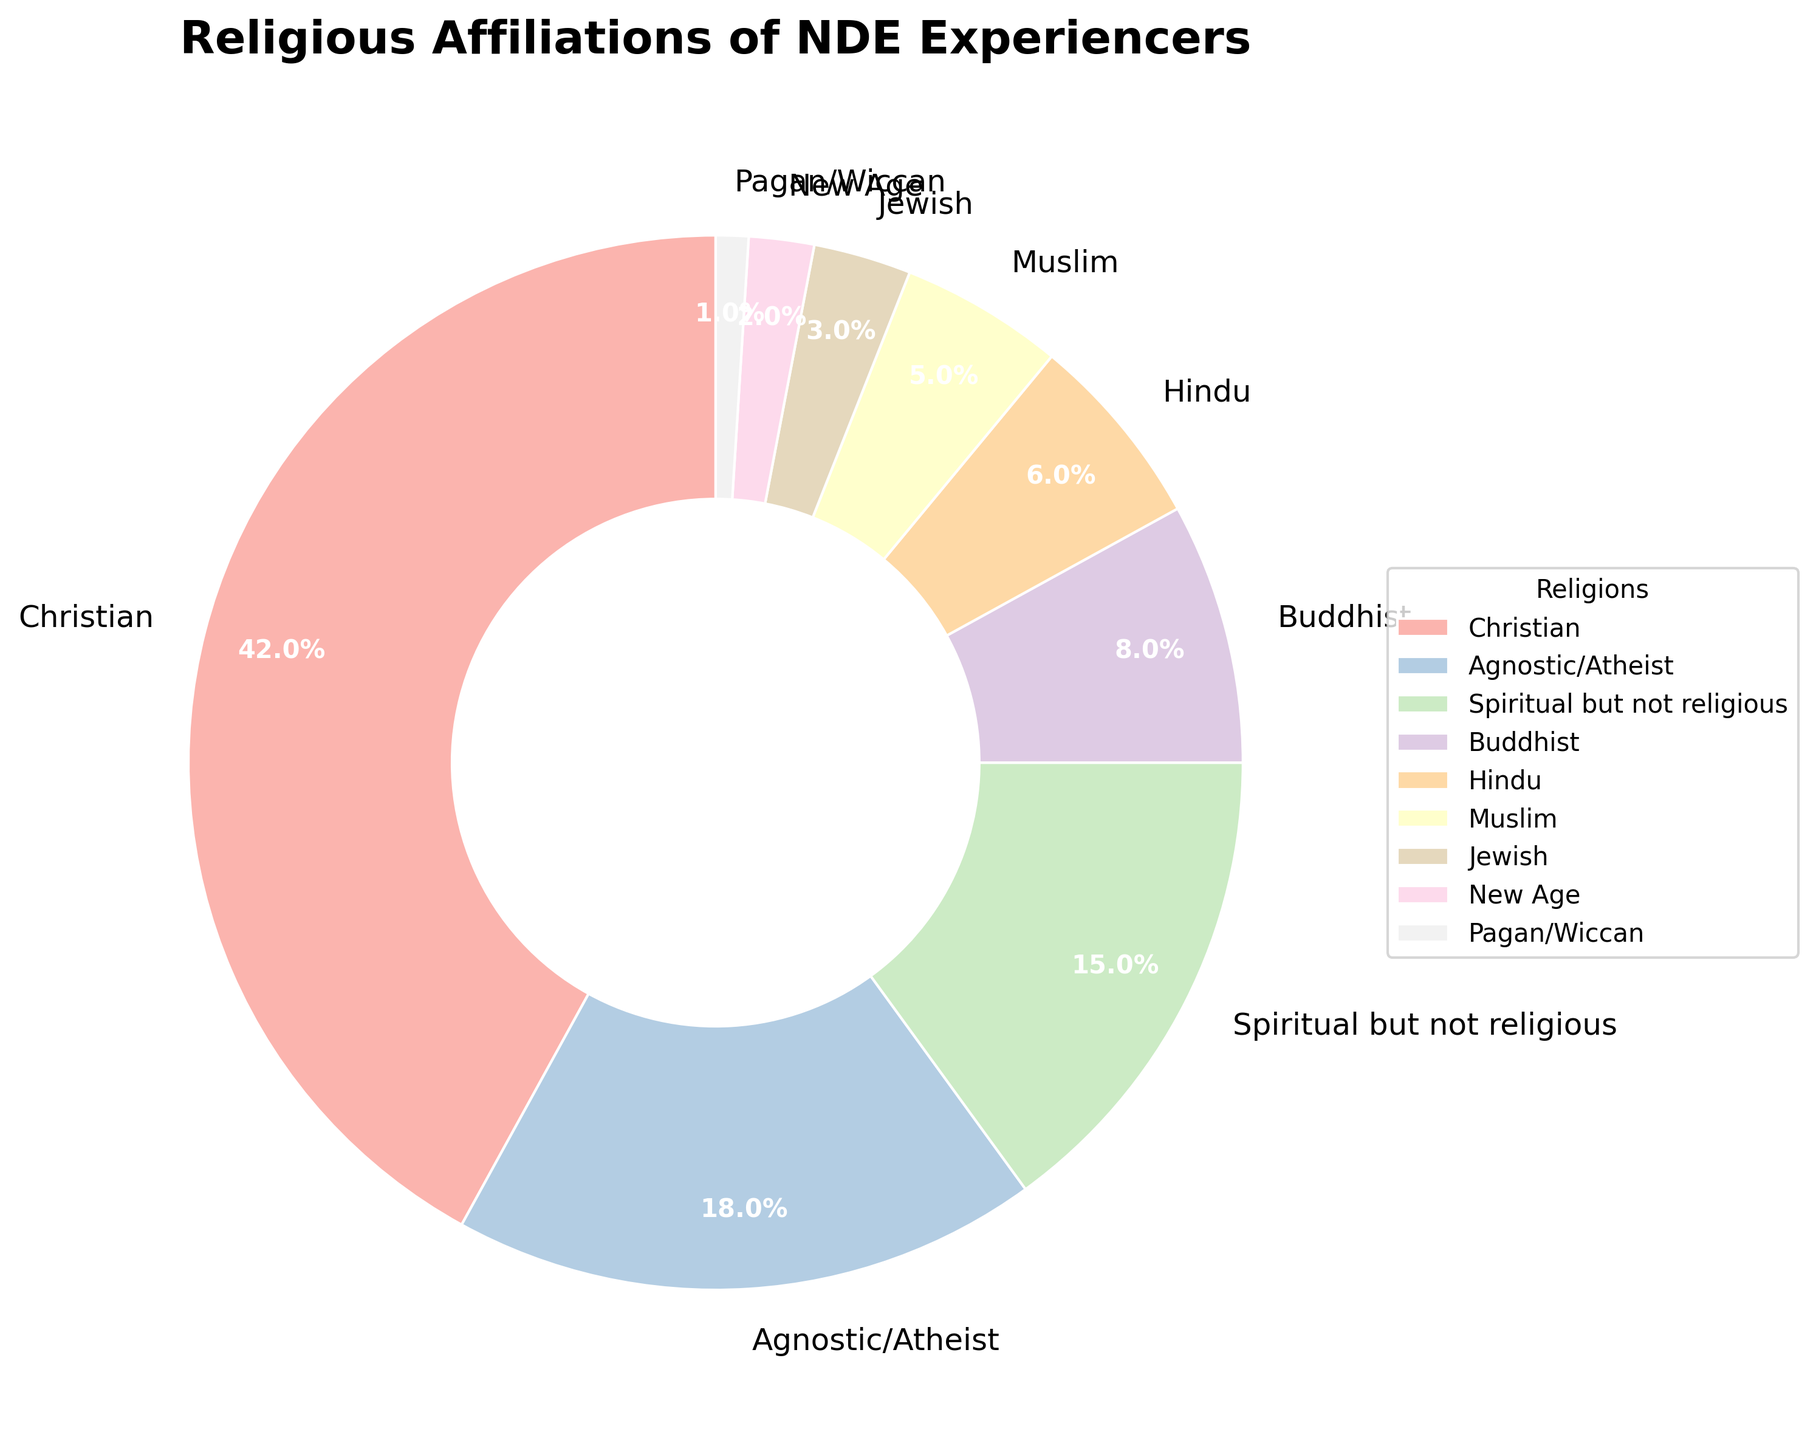Which religious affiliation has the highest percentage of NDE experiencers? The pie chart shows that the section labeled 'Christian' occupies the largest portion of the chart, which reflects the highest percentage.
Answer: Christian What's the combined percentage of NDE experiencers who identify as either 'Christian' or 'Agnostic/Atheist'? According to the pie chart, 'Christian' has 42% and 'Agnostic/Atheist' has 18%. Adding these percentages gives 42 + 18 = 60%.
Answer: 60% How does the percentage of 'Spiritual but not religious' NDE experiencers compare to that of 'Buddhist' and 'Hindu' combined? 'Spiritual but not religious' is 15%. 'Buddhist' is 8% and 'Hindu' is 6%, so their combined percentage is 8 + 6 = 14%. Since 15% is greater than 14%, 'Spiritual but not religious' has a higher percentage.
Answer: Higher What is the percentage difference between 'Muslim' and 'Jewish' NDE experiencers? 'Muslim' is 5% and 'Jewish' is 3%. Subtracting these percentages gives 5% - 3% = 2%.
Answer: 2% What is the total percentage for religions with values below 10%? Summing the percentages of 'Buddhist' (8%), 'Hindu' (6%), 'Muslim' (5%), 'Jewish' (3%), 'New Age' (2%), and 'Pagan/Wiccan' (1%) gives 8 + 6 + 5 + 3 + 2 + 1 = 25%.
Answer: 25% Which religious affiliation is represented by the smallest section of the pie chart? The smallest section in the pie chart is labeled 'Pagan/Wiccan', representing 1%.
Answer: Pagan/Wiccan What percentage of NDE experiencers categorize themselves as either 'Muslim', 'Jewish', 'New Age', or 'Pagan/Wiccan'? The percentages for 'Muslim' (5%), 'Jewish' (3%), 'New Age' (2%), and 'Pagan/Wiccan' (1%) are summed to give 5 + 3 + 2 + 1 = 11%.
Answer: 11% Among the listed religious affiliations, which group has exactly twice the percentage of 'Hindu' NDE experiencers? 'Hindu' has 6%. The group with twice this percentage is 'Agnostic/Atheist', which has 18%, but this is three times, not twice, so no group has exactly twice the percentage of 'Hindu'.
Answer: None 